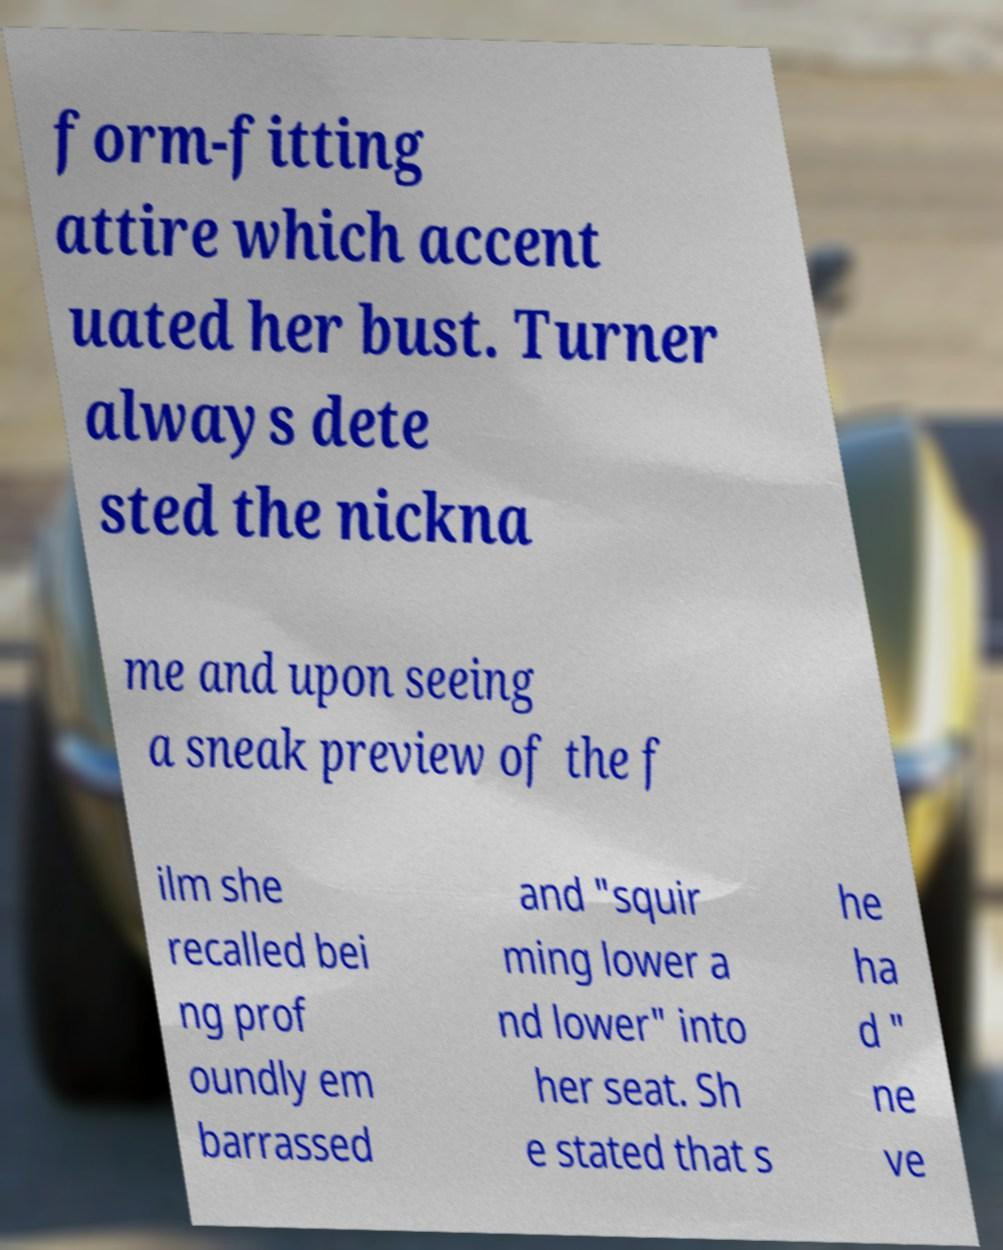Can you accurately transcribe the text from the provided image for me? form-fitting attire which accent uated her bust. Turner always dete sted the nickna me and upon seeing a sneak preview of the f ilm she recalled bei ng prof oundly em barrassed and "squir ming lower a nd lower" into her seat. Sh e stated that s he ha d " ne ve 